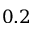<formula> <loc_0><loc_0><loc_500><loc_500>0 . 2</formula> 